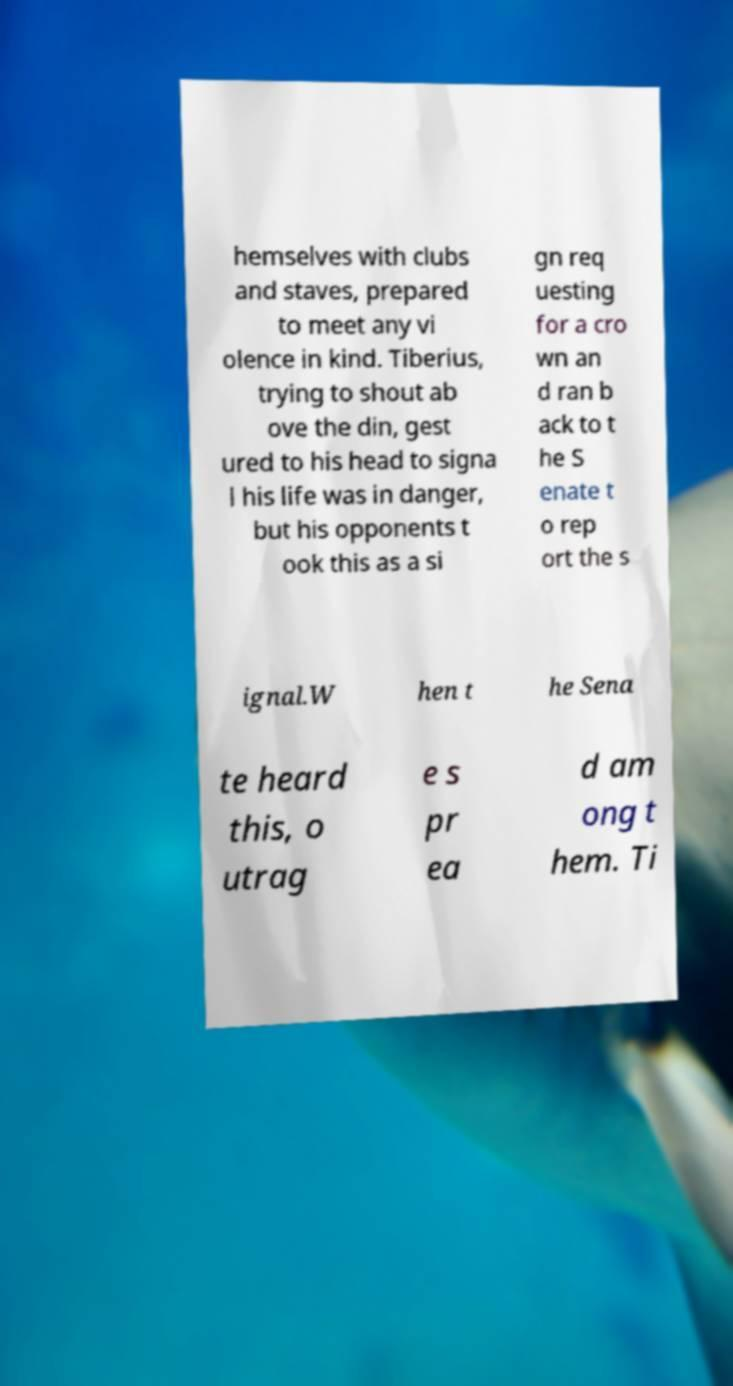Please read and relay the text visible in this image. What does it say? hemselves with clubs and staves, prepared to meet any vi olence in kind. Tiberius, trying to shout ab ove the din, gest ured to his head to signa l his life was in danger, but his opponents t ook this as a si gn req uesting for a cro wn an d ran b ack to t he S enate t o rep ort the s ignal.W hen t he Sena te heard this, o utrag e s pr ea d am ong t hem. Ti 